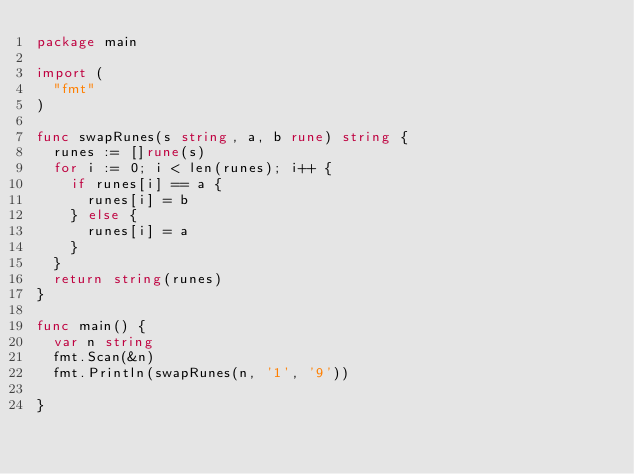Convert code to text. <code><loc_0><loc_0><loc_500><loc_500><_Go_>package main

import (
  "fmt"
)

func swapRunes(s string, a, b rune) string {
  runes := []rune(s)
  for i := 0; i < len(runes); i++ {
    if runes[i] == a {
      runes[i] = b
    } else {
      runes[i] = a
    }
  }
  return string(runes)
}

func main() {
  var n string
  fmt.Scan(&n)
  fmt.Println(swapRunes(n, '1', '9'))

}</code> 